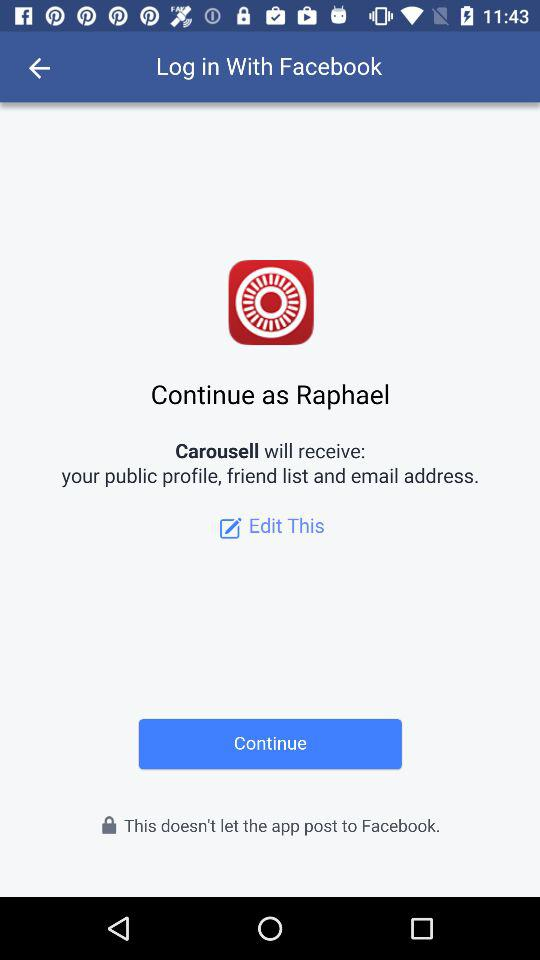Which option is selected?
When the provided information is insufficient, respond with <no answer>. <no answer> 